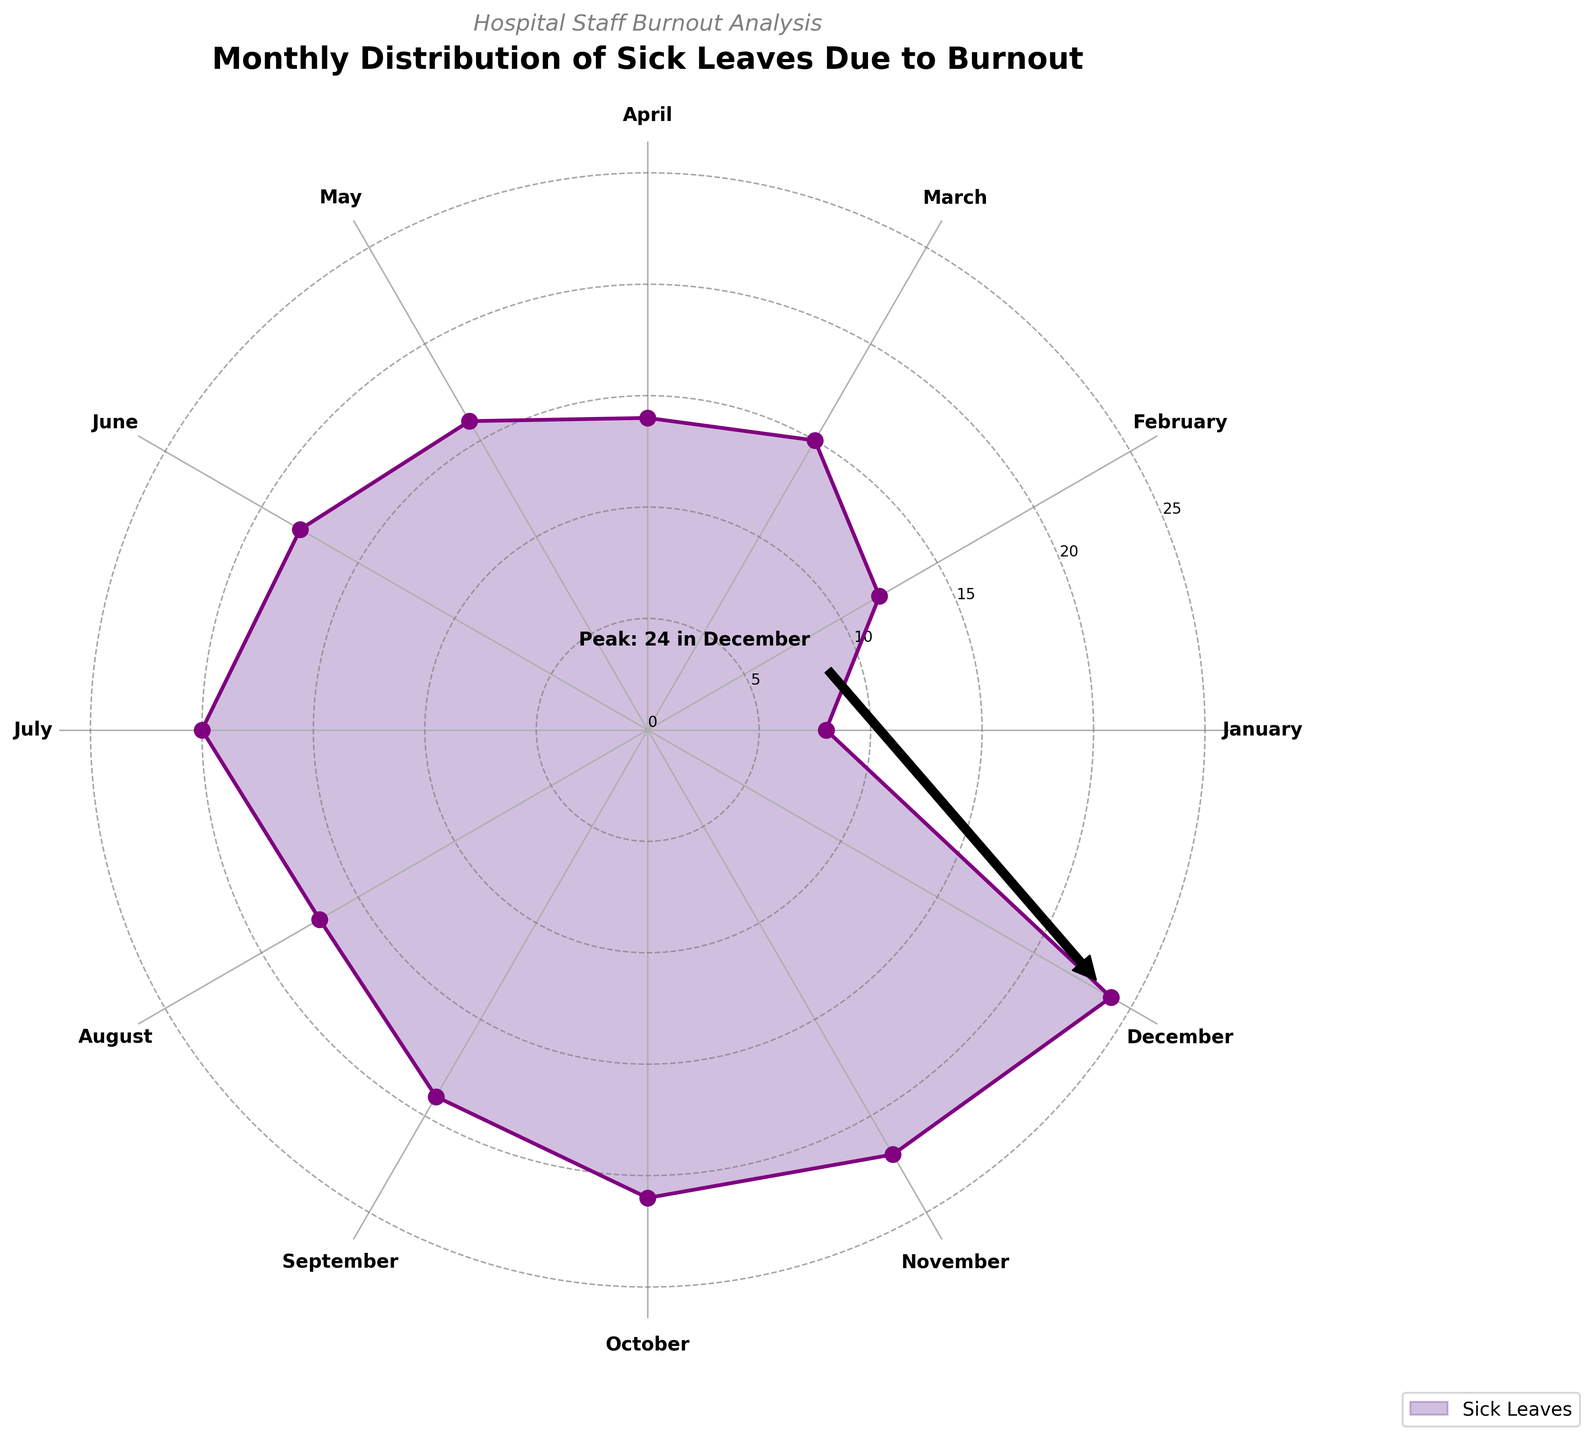What is the title of the chart? The title is positioned at the top center of the chart. It provides a summary of what the chart represents.
Answer: Monthly Distribution of Sick Leaves Due to Burnout Which month has the highest number of sick leaves? December has the highest value on the radial axis and is also annotated directly on the chart.
Answer: December By how many sick leaves does August exceed January? August has 17 sick leaves, while January has 8. Subtract 8 from 17 to get the difference.
Answer: 9 What is the average number of sick leaves taken per month? Add all monthly values and divide by 12 (the number of months). (8 + 12 + 15 + 14 + 16 + 18 + 20 + 17 + 19 + 21 + 22 + 24) / 12 = 17.25
Answer: 17.25 Which month had fewer sick leaves, February or April? Compare the sick leaves for February (12) and April (14). February is fewer.
Answer: February What’s the combined total of sick leaves for June, July, and August? Add the sick leaves for June (18), July (20), and August (17). 18 + 20 + 17 = 55
Answer: 55 Is there a noticeable trend in the number of sick leaves across months? The number of sick leaves gradually increases from January to December, indicating a rising trend.
Answer: Yes How many months had fewer than 15 sick leaves? January, February, March, and April had fewer than 15 sick leaves. Count them.
Answer: 4 By how many sick leaves does November fall short of December? Compare sick leaves for November (22) and December (24). Subtract 22 from 24.
Answer: 2 In which month do sick leaves first exceed 20? Identify the first month surpassing 20 sick leaves. October shows 21.
Answer: October 